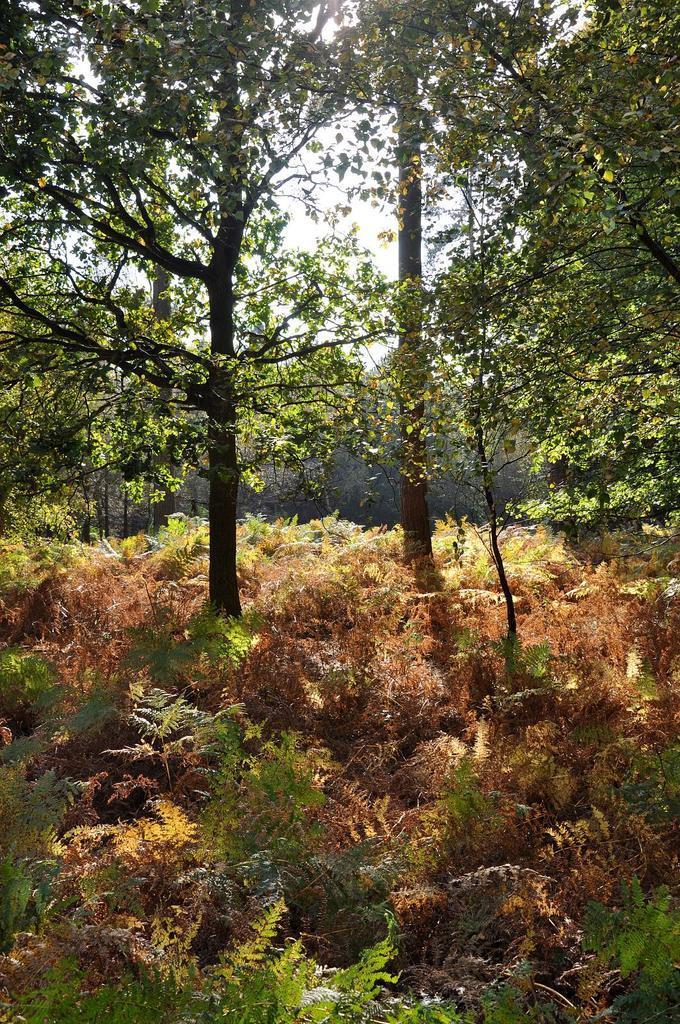Can you describe this image briefly? In this image we can see small plants, trees and the sky in the background. 